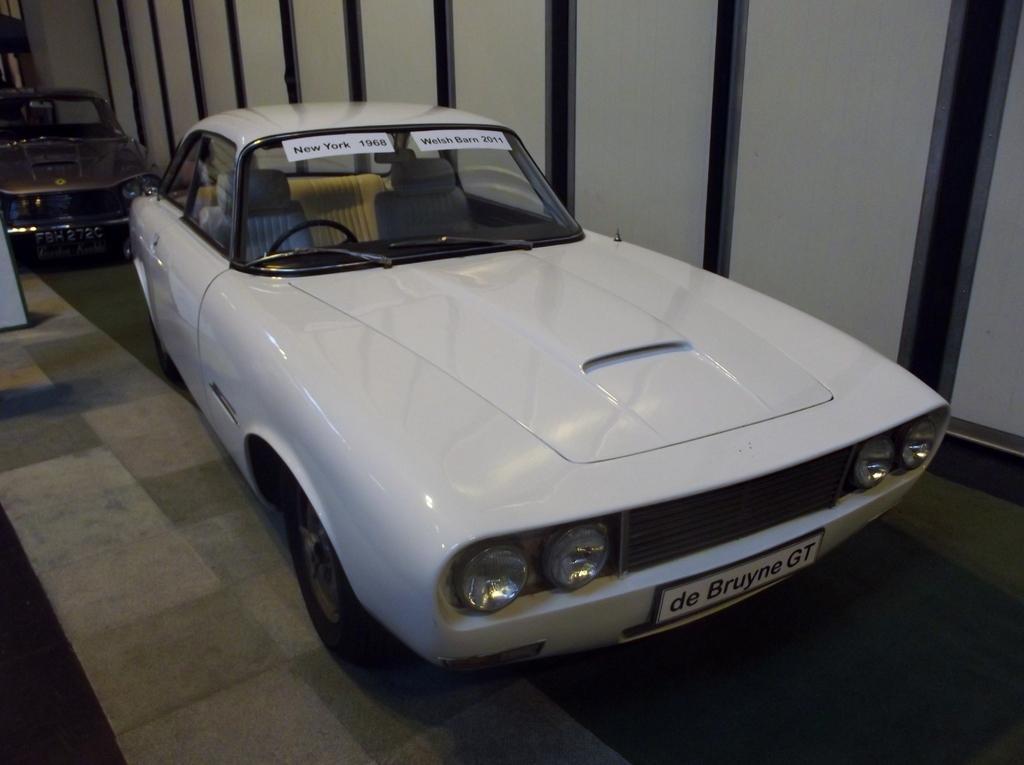How would you summarize this image in a sentence or two? This is the picture of a place where we have a car to which there are two papers pasted on it and behind there is an other car. 